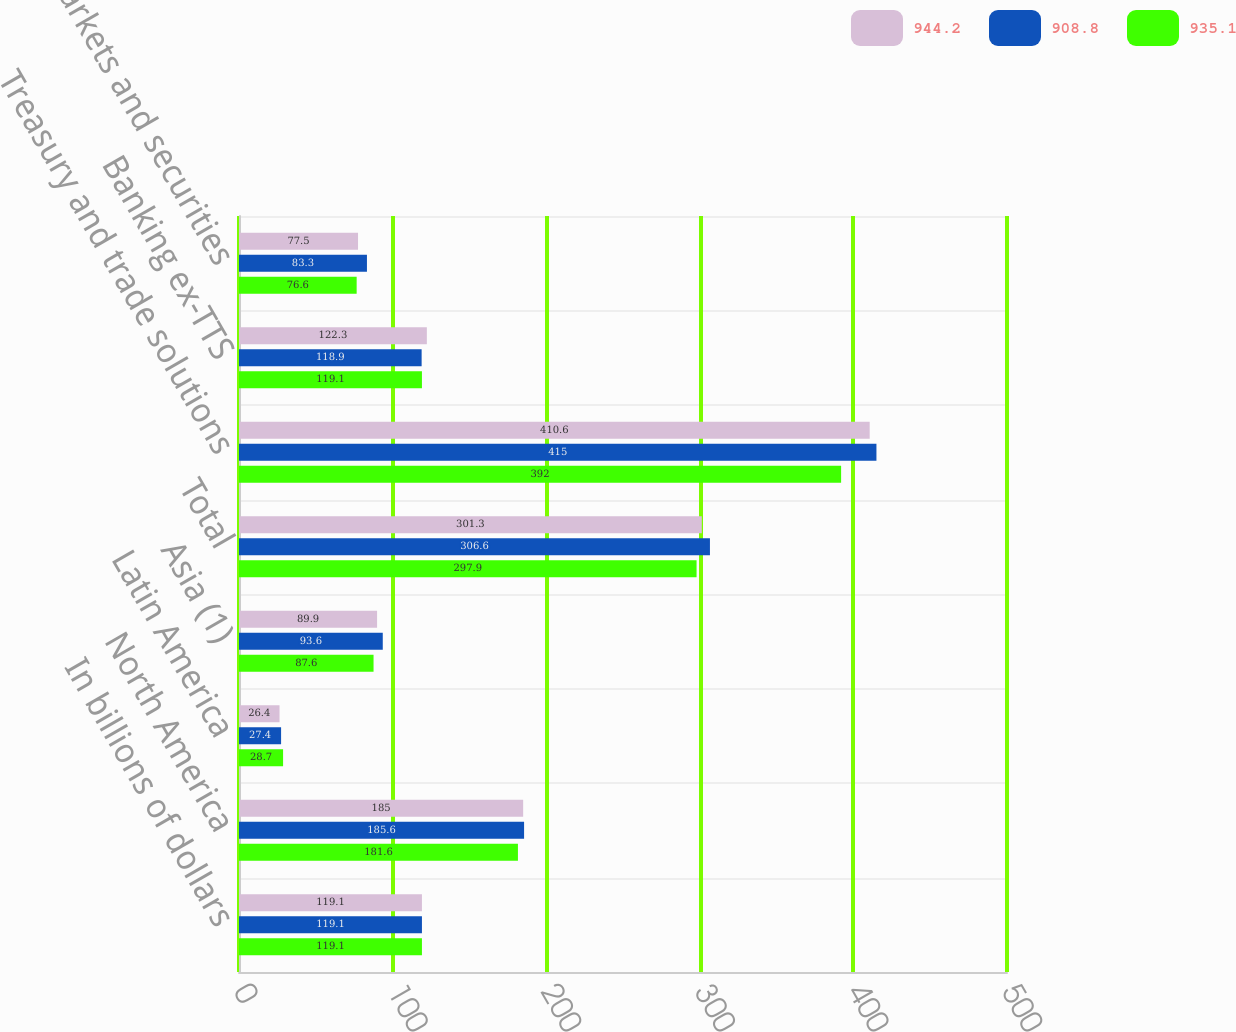Convert chart. <chart><loc_0><loc_0><loc_500><loc_500><stacked_bar_chart><ecel><fcel>In billions of dollars<fcel>North America<fcel>Latin America<fcel>Asia (1)<fcel>Total<fcel>Treasury and trade solutions<fcel>Banking ex-TTS<fcel>Markets and securities<nl><fcel>944.2<fcel>119.1<fcel>185<fcel>26.4<fcel>89.9<fcel>301.3<fcel>410.6<fcel>122.3<fcel>77.5<nl><fcel>908.8<fcel>119.1<fcel>185.6<fcel>27.4<fcel>93.6<fcel>306.6<fcel>415<fcel>118.9<fcel>83.3<nl><fcel>935.1<fcel>119.1<fcel>181.6<fcel>28.7<fcel>87.6<fcel>297.9<fcel>392<fcel>119.1<fcel>76.6<nl></chart> 